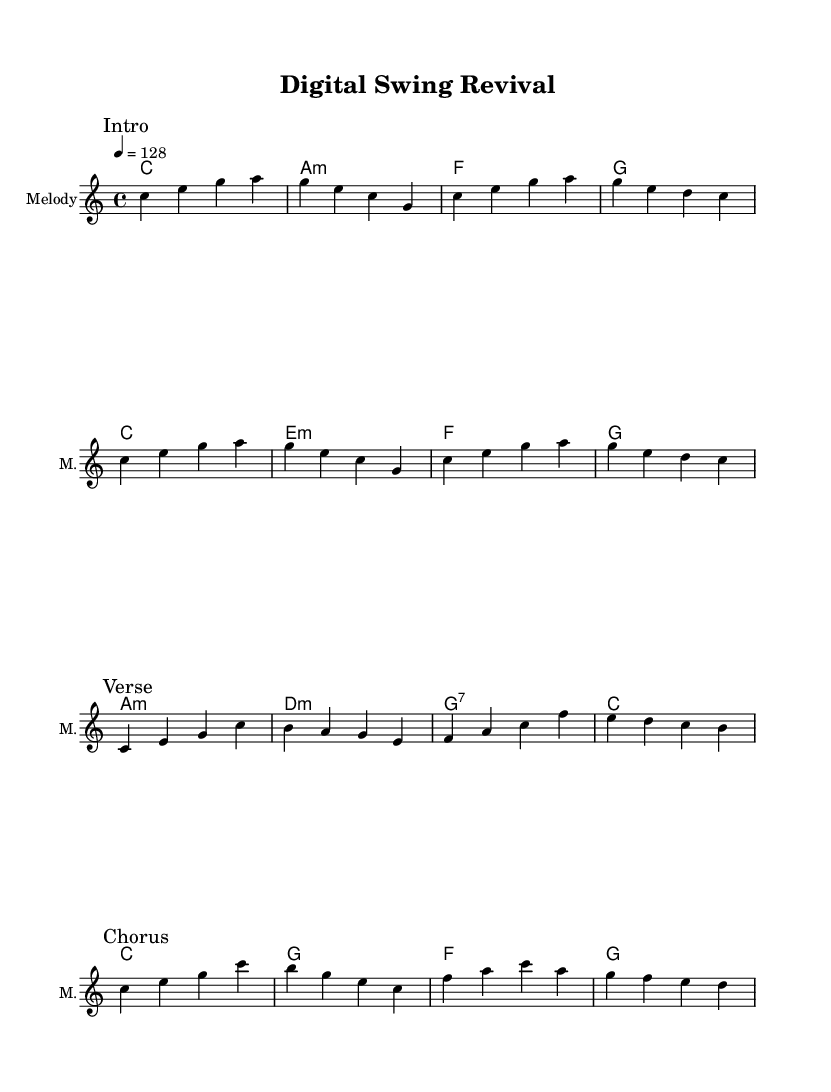What is the key signature of this music? The key signature is indicated as C major, which means there are no sharps or flats in the score. C major is derived from the musical notes present in the staff where no accidentals are shown.
Answer: C major What is the time signature of this music? The time signature is shown as 4/4, which indicates that there are four beats per measure and a quarter note gets one beat. This can be found in the global settings at the beginning of the score.
Answer: 4/4 What is the tempo marking for this piece? The tempo marking indicates that the piece should be played at a speed of 128 beats per minute, as noted by the tempo instruction in the score. This is typically represented in a '4 = 128' format, referring to the quarter note.
Answer: 128 How many measures are there in the intro melody? The intro melody consists of four measures, which can be counted directly from the notation where each bar line indicates the end of a measure.
Answer: 4 What is the first chord in the harmonies? The first chord in the harmonies section is C major, as indicated by the chord notation provided in the score. It is the first symbol found in the chord mode section at the beginning.
Answer: C What is the structure of the melody sections in the score? The structure of the melody is comprised of an intro, a verse, and a chorus, as clearly labeled by the marks in the score. Each section has a different melody which showcases variation typical in electro-swing fusions.
Answer: Intro, Verse, Chorus What musical style is combined in this piece? The piece is an electro-swing fusion, which merges vintage jazz samples with contemporary EDM elements, as suggested by the title "Digital Swing Revival" and the use of jazz melodies with electronic rhythms in the harmonies.
Answer: Electro-swing fusion 